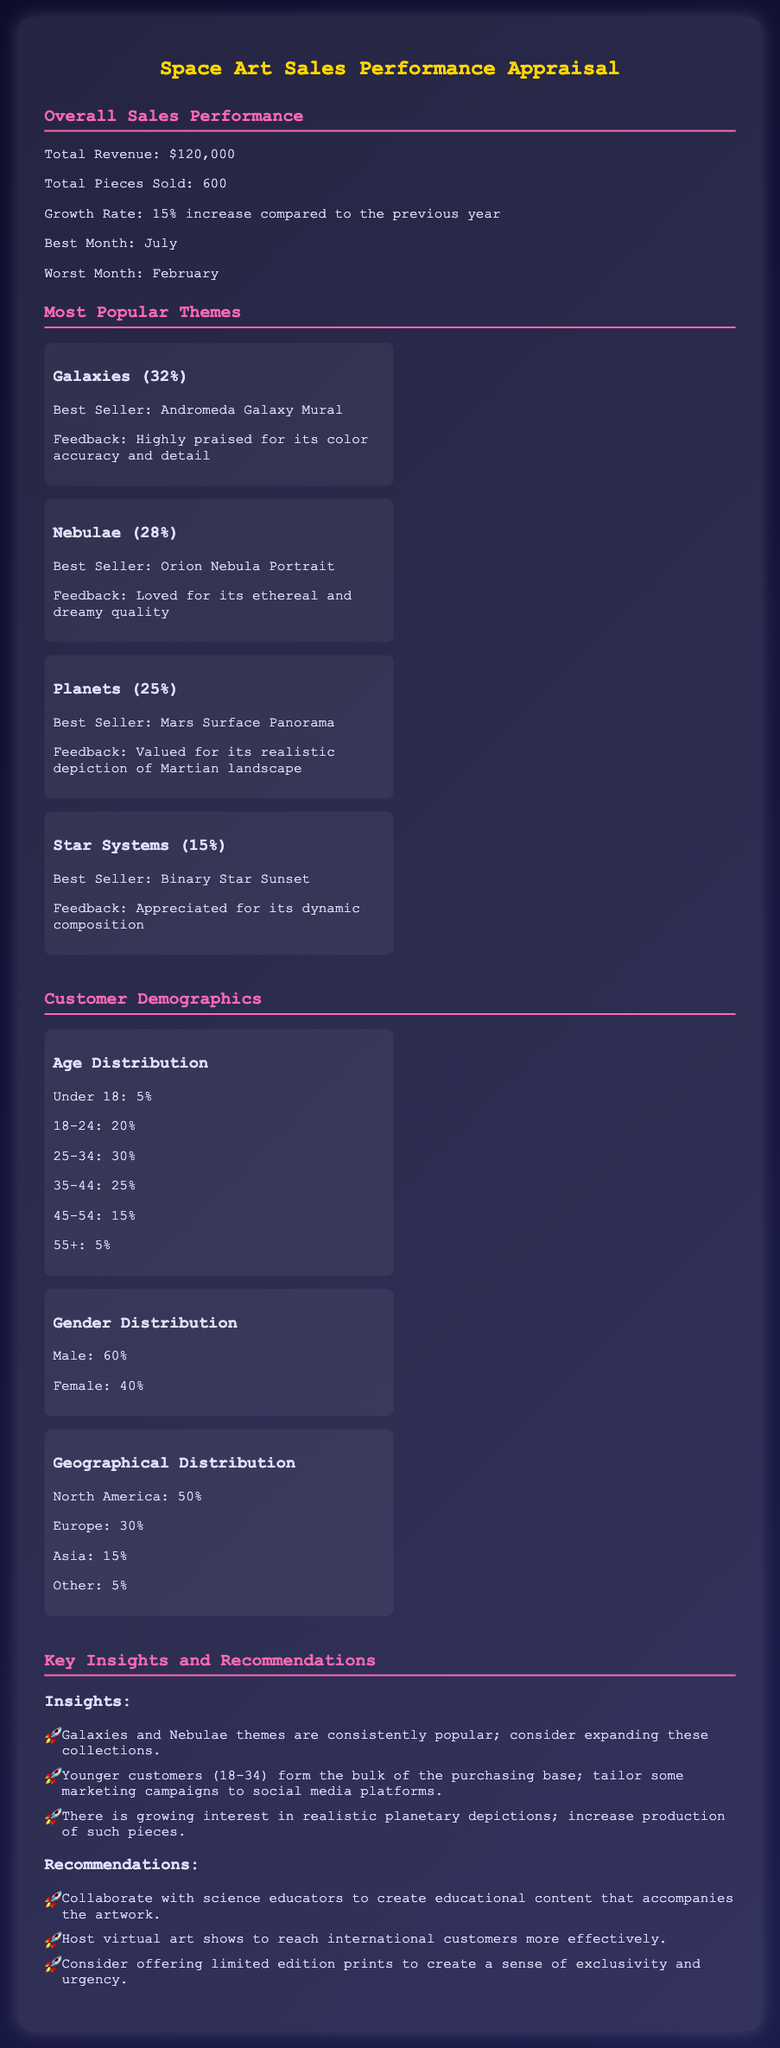What is the total revenue? The total revenue is stated in the document as $120,000.
Answer: $120,000 What percentage of sales did Galaxies account for? Galaxies accounted for 32% of sales, as mentioned in the themes section.
Answer: 32% Which month had the highest sales? The document indicates that July was the best month for sales.
Answer: July What is the best-seller theme? The most popular theme based on percentage is Galaxies.
Answer: Galaxies What age group forms the largest percentage of customers? The age group of 25-34 forms the largest percentage at 30%.
Answer: 25-34 How many pieces were sold in total? The total number of pieces sold is specified as 600.
Answer: 600 What is the feedback for the Orion Nebula Portrait? The feedback notes it is loved for its ethereal and dreamy quality.
Answer: Ethereal and dreamy quality What is the percentage of Male customers? The gender distribution indicates that Male customers account for 60%.
Answer: 60% Which geographical region accounts for the smallest percentage of sales? The smallest geographical distribution is Other, accounting for 5%.
Answer: 5% 